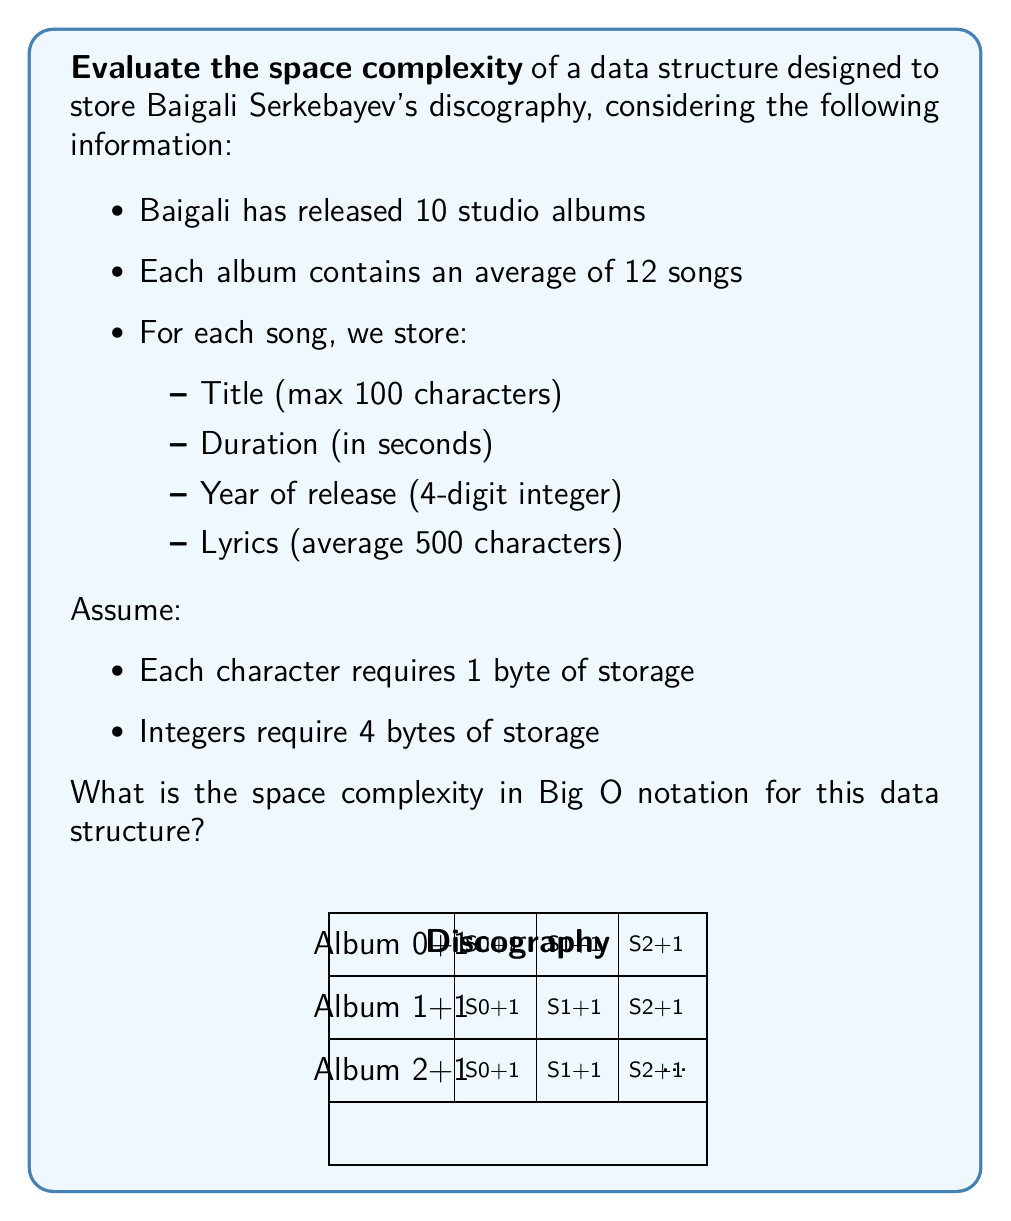Provide a solution to this math problem. Let's break down the space requirements step-by-step:

1. For each song, we store:
   - Title: 100 characters * 1 byte = 100 bytes
   - Duration: 1 integer * 4 bytes = 4 bytes
   - Year: 1 integer * 4 bytes = 4 bytes
   - Lyrics: 500 characters * 1 byte = 500 bytes
   Total per song: 100 + 4 + 4 + 500 = 608 bytes

2. Each album contains an average of 12 songs:
   12 songs * 608 bytes = 7,296 bytes per album

3. There are 10 studio albums:
   10 albums * 7,296 bytes = 72,960 bytes total

To determine the space complexity, we need to express this in terms of the input size. Let's define $n$ as the number of albums in the discography.

The total space used can be expressed as:
$$ S(n) = n * (\text{songs per album} * \text{bytes per song}) $$
$$ S(n) = n * (12 * 608) = 7,296n \text{ bytes} $$

In Big O notation, we ignore constant factors and lower-order terms. Therefore, the space complexity is $O(n)$, where $n$ is the number of albums.

This linear space complexity holds true even if the number of songs per album or the size of each song's data varies slightly, as long as these variations are bounded by a constant.
Answer: $O(n)$ 